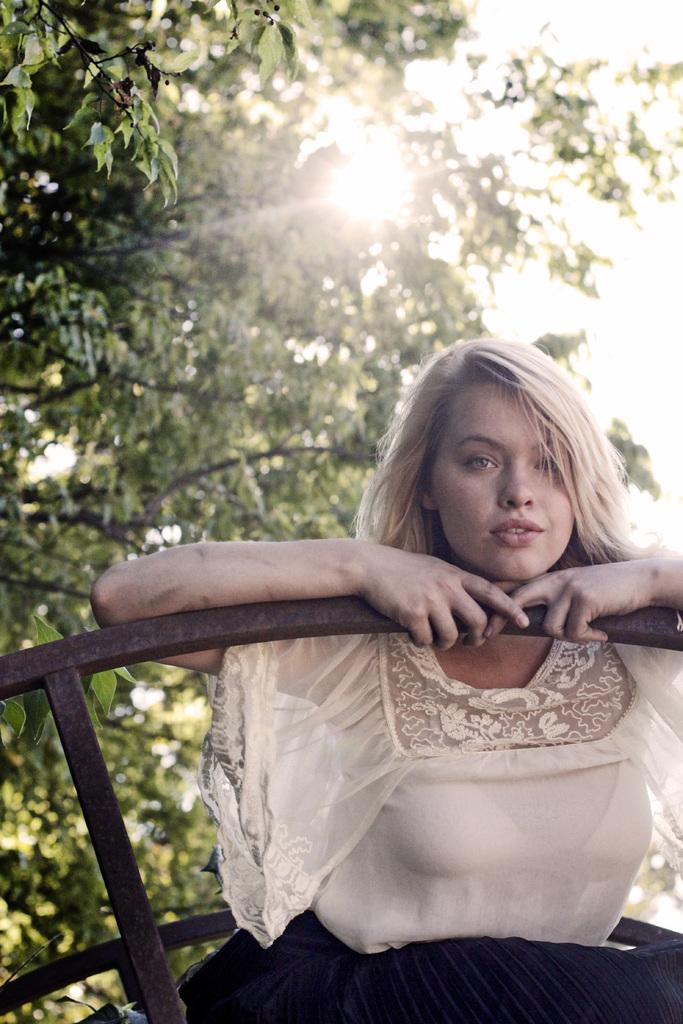Who is present in the image? There is a woman in the image. Where is the woman located in the image? The woman is located towards the right bottom of the image. What is the woman wearing? The woman is wearing a white dress. What is the woman holding in the image? The woman is holding a hand-grill. What can be seen in the background of the image? There is a tree and the sun visible in the background of the image. What type of baseball equipment can be seen in the image? There is no baseball equipment present in the image. What is the woman's interest in the edge of the image? The woman's interest is not mentioned in the image, and there is no reference to an edge in the provided facts. 